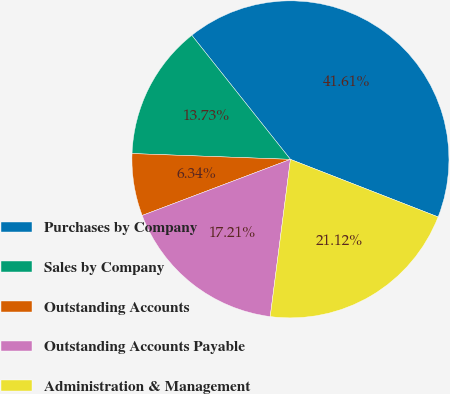<chart> <loc_0><loc_0><loc_500><loc_500><pie_chart><fcel>Purchases by Company<fcel>Sales by Company<fcel>Outstanding Accounts<fcel>Outstanding Accounts Payable<fcel>Administration & Management<nl><fcel>41.61%<fcel>13.73%<fcel>6.34%<fcel>17.21%<fcel>21.12%<nl></chart> 